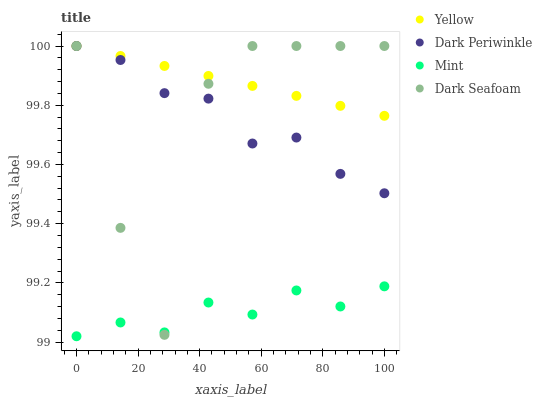Does Mint have the minimum area under the curve?
Answer yes or no. Yes. Does Yellow have the maximum area under the curve?
Answer yes or no. Yes. Does Dark Periwinkle have the minimum area under the curve?
Answer yes or no. No. Does Dark Periwinkle have the maximum area under the curve?
Answer yes or no. No. Is Yellow the smoothest?
Answer yes or no. Yes. Is Dark Seafoam the roughest?
Answer yes or no. Yes. Is Mint the smoothest?
Answer yes or no. No. Is Mint the roughest?
Answer yes or no. No. Does Mint have the lowest value?
Answer yes or no. Yes. Does Dark Periwinkle have the lowest value?
Answer yes or no. No. Does Yellow have the highest value?
Answer yes or no. Yes. Does Mint have the highest value?
Answer yes or no. No. Is Mint less than Yellow?
Answer yes or no. Yes. Is Dark Periwinkle greater than Mint?
Answer yes or no. Yes. Does Yellow intersect Dark Periwinkle?
Answer yes or no. Yes. Is Yellow less than Dark Periwinkle?
Answer yes or no. No. Is Yellow greater than Dark Periwinkle?
Answer yes or no. No. Does Mint intersect Yellow?
Answer yes or no. No. 